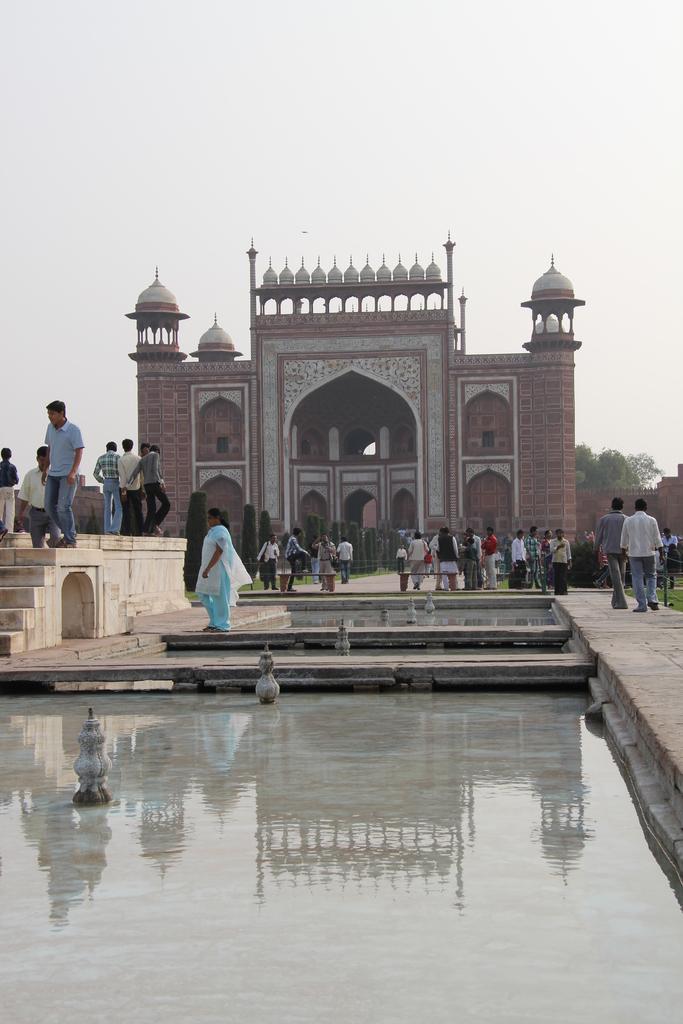Can you describe this image briefly? In this image I can see water in the front and in the background I can see number of people are standing. I can also see a mosque in the background and on the right side of it I can see a tree. 